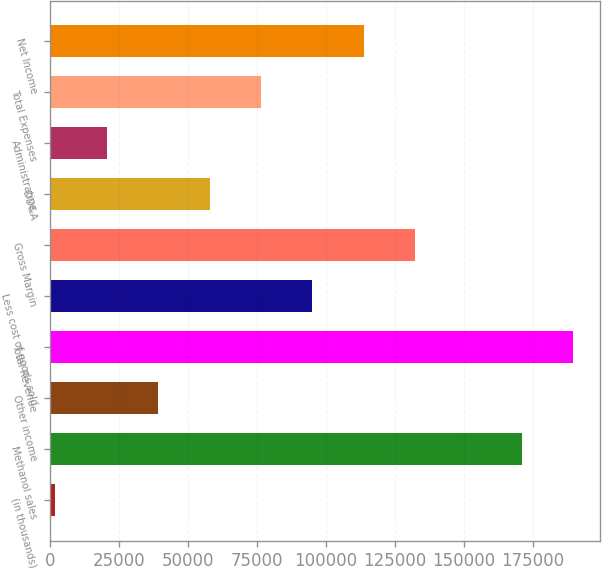Convert chart. <chart><loc_0><loc_0><loc_500><loc_500><bar_chart><fcel>(in thousands)<fcel>Methanol sales<fcel>Other income<fcel>Total Revenue<fcel>Less cost of goods sold<fcel>Gross Margin<fcel>DD&A<fcel>Administrative<fcel>Total Expenses<fcel>Net Income<nl><fcel>2003<fcel>171126<fcel>39274<fcel>189762<fcel>95180.5<fcel>132452<fcel>57909.5<fcel>20638.5<fcel>76545<fcel>113816<nl></chart> 